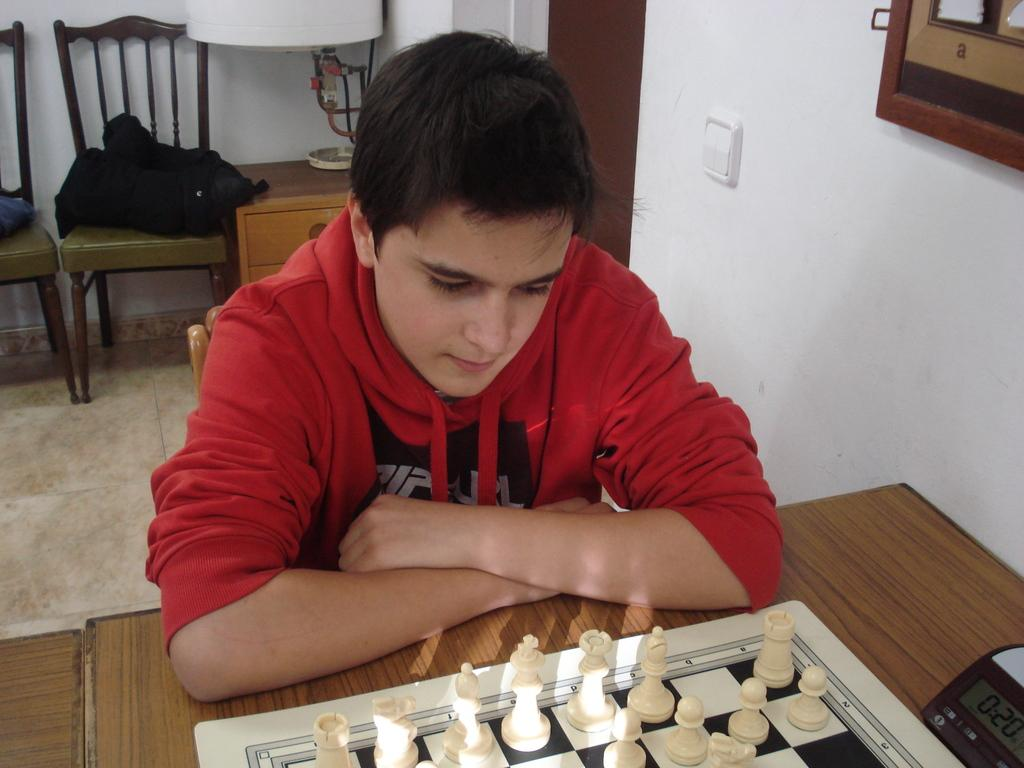Who is present in the image? There is a man in the image. What is the man wearing? The man is wearing a red shirt. What is the man doing in the image? The man is sitting on a chair. What can be seen on the table in the image? There is a chessboard on the table. How many chairs are visible in the image? There are three chairs visible in the image: one the man is sitting on and two behind him. What is located behind the man in the man in the image? There is a desk behind the man. What month is it in the image? The image does not provide any information about the month, so it cannot be determined from the image. Can you see a lake in the image? There is no lake present in the image. Is there a volleyball game happening in the image? There is no volleyball game or any reference to volleyball in the image. 